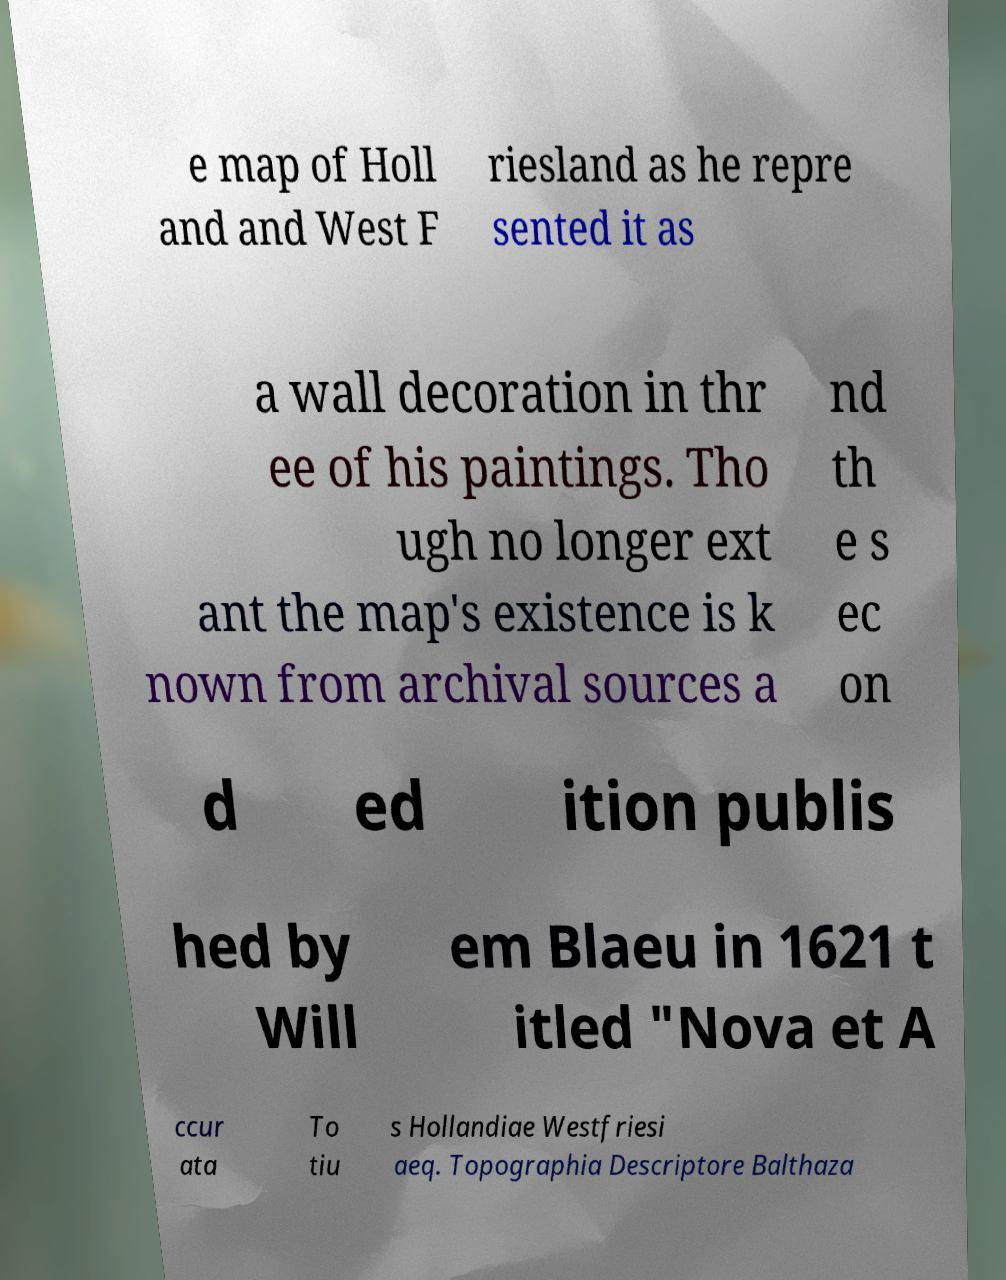What messages or text are displayed in this image? I need them in a readable, typed format. e map of Holl and and West F riesland as he repre sented it as a wall decoration in thr ee of his paintings. Tho ugh no longer ext ant the map's existence is k nown from archival sources a nd th e s ec on d ed ition publis hed by Will em Blaeu in 1621 t itled "Nova et A ccur ata To tiu s Hollandiae Westfriesi aeq. Topographia Descriptore Balthaza 